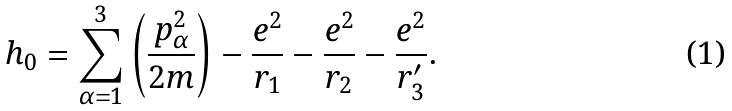Convert formula to latex. <formula><loc_0><loc_0><loc_500><loc_500>h _ { 0 } = \sum ^ { 3 } _ { \alpha = 1 } \left ( \frac { p ^ { 2 } _ { \alpha } } { 2 m } \right ) - \frac { e ^ { 2 } } { r _ { 1 } } - \frac { e ^ { 2 } } { r _ { 2 } } - \frac { e ^ { 2 } } { r ^ { \prime } _ { 3 } } .</formula> 